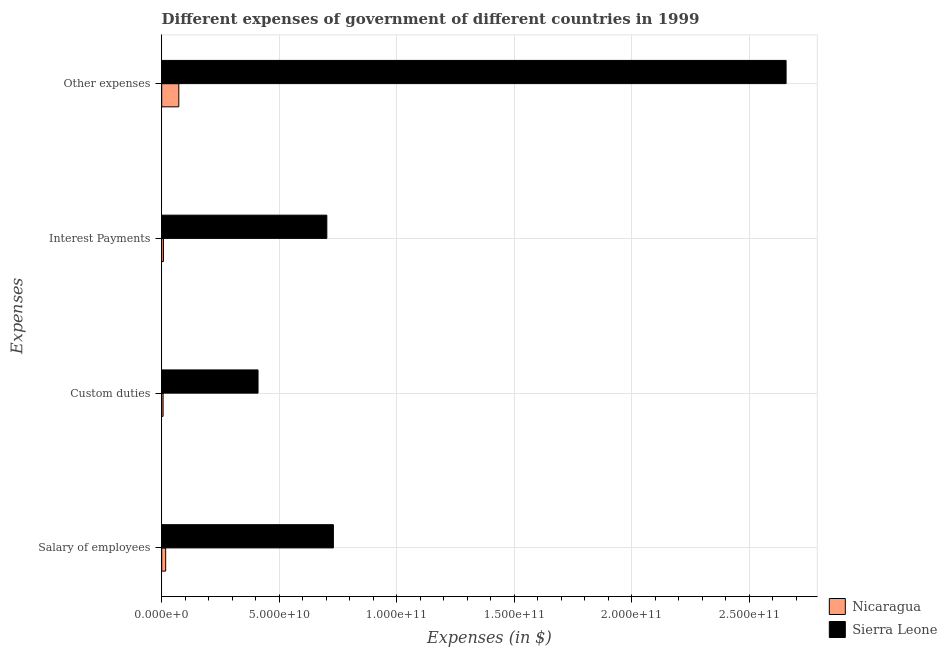How many groups of bars are there?
Give a very brief answer. 4. Are the number of bars per tick equal to the number of legend labels?
Your answer should be compact. Yes. Are the number of bars on each tick of the Y-axis equal?
Provide a short and direct response. Yes. How many bars are there on the 3rd tick from the top?
Offer a very short reply. 2. What is the label of the 2nd group of bars from the top?
Keep it short and to the point. Interest Payments. What is the amount spent on other expenses in Nicaragua?
Offer a very short reply. 7.27e+09. Across all countries, what is the maximum amount spent on custom duties?
Give a very brief answer. 4.10e+1. Across all countries, what is the minimum amount spent on other expenses?
Provide a short and direct response. 7.27e+09. In which country was the amount spent on other expenses maximum?
Provide a short and direct response. Sierra Leone. In which country was the amount spent on other expenses minimum?
Offer a terse response. Nicaragua. What is the total amount spent on custom duties in the graph?
Ensure brevity in your answer.  4.16e+1. What is the difference between the amount spent on salary of employees in Sierra Leone and that in Nicaragua?
Make the answer very short. 7.13e+1. What is the difference between the amount spent on interest payments in Nicaragua and the amount spent on custom duties in Sierra Leone?
Provide a succinct answer. -4.02e+1. What is the average amount spent on salary of employees per country?
Make the answer very short. 3.74e+1. What is the difference between the amount spent on interest payments and amount spent on custom duties in Sierra Leone?
Ensure brevity in your answer.  2.93e+1. In how many countries, is the amount spent on salary of employees greater than 100000000000 $?
Your response must be concise. 0. What is the ratio of the amount spent on custom duties in Sierra Leone to that in Nicaragua?
Provide a succinct answer. 69.95. Is the amount spent on other expenses in Nicaragua less than that in Sierra Leone?
Offer a very short reply. Yes. What is the difference between the highest and the second highest amount spent on interest payments?
Provide a succinct answer. 6.95e+1. What is the difference between the highest and the lowest amount spent on custom duties?
Make the answer very short. 4.04e+1. In how many countries, is the amount spent on custom duties greater than the average amount spent on custom duties taken over all countries?
Provide a succinct answer. 1. Is the sum of the amount spent on salary of employees in Sierra Leone and Nicaragua greater than the maximum amount spent on custom duties across all countries?
Keep it short and to the point. Yes. Is it the case that in every country, the sum of the amount spent on salary of employees and amount spent on other expenses is greater than the sum of amount spent on interest payments and amount spent on custom duties?
Your answer should be very brief. No. What does the 2nd bar from the top in Salary of employees represents?
Your response must be concise. Nicaragua. What does the 2nd bar from the bottom in Other expenses represents?
Your response must be concise. Sierra Leone. How many bars are there?
Provide a succinct answer. 8. Are all the bars in the graph horizontal?
Your answer should be very brief. Yes. How many countries are there in the graph?
Offer a very short reply. 2. Does the graph contain any zero values?
Your answer should be very brief. No. Does the graph contain grids?
Your answer should be compact. Yes. How many legend labels are there?
Make the answer very short. 2. What is the title of the graph?
Make the answer very short. Different expenses of government of different countries in 1999. What is the label or title of the X-axis?
Offer a very short reply. Expenses (in $). What is the label or title of the Y-axis?
Your answer should be compact. Expenses. What is the Expenses (in $) in Nicaragua in Salary of employees?
Keep it short and to the point. 1.68e+09. What is the Expenses (in $) of Sierra Leone in Salary of employees?
Offer a very short reply. 7.30e+1. What is the Expenses (in $) of Nicaragua in Custom duties?
Offer a terse response. 5.86e+08. What is the Expenses (in $) in Sierra Leone in Custom duties?
Ensure brevity in your answer.  4.10e+1. What is the Expenses (in $) of Nicaragua in Interest Payments?
Your answer should be very brief. 7.43e+08. What is the Expenses (in $) of Sierra Leone in Interest Payments?
Ensure brevity in your answer.  7.02e+1. What is the Expenses (in $) in Nicaragua in Other expenses?
Provide a short and direct response. 7.27e+09. What is the Expenses (in $) in Sierra Leone in Other expenses?
Keep it short and to the point. 2.66e+11. Across all Expenses, what is the maximum Expenses (in $) of Nicaragua?
Offer a terse response. 7.27e+09. Across all Expenses, what is the maximum Expenses (in $) of Sierra Leone?
Your answer should be compact. 2.66e+11. Across all Expenses, what is the minimum Expenses (in $) in Nicaragua?
Provide a succinct answer. 5.86e+08. Across all Expenses, what is the minimum Expenses (in $) in Sierra Leone?
Keep it short and to the point. 4.10e+1. What is the total Expenses (in $) of Nicaragua in the graph?
Make the answer very short. 1.03e+1. What is the total Expenses (in $) of Sierra Leone in the graph?
Your answer should be very brief. 4.50e+11. What is the difference between the Expenses (in $) in Nicaragua in Salary of employees and that in Custom duties?
Your response must be concise. 1.10e+09. What is the difference between the Expenses (in $) of Sierra Leone in Salary of employees and that in Custom duties?
Provide a succinct answer. 3.21e+1. What is the difference between the Expenses (in $) of Nicaragua in Salary of employees and that in Interest Payments?
Give a very brief answer. 9.40e+08. What is the difference between the Expenses (in $) of Sierra Leone in Salary of employees and that in Interest Payments?
Keep it short and to the point. 2.79e+09. What is the difference between the Expenses (in $) in Nicaragua in Salary of employees and that in Other expenses?
Provide a succinct answer. -5.59e+09. What is the difference between the Expenses (in $) of Sierra Leone in Salary of employees and that in Other expenses?
Provide a short and direct response. -1.93e+11. What is the difference between the Expenses (in $) in Nicaragua in Custom duties and that in Interest Payments?
Give a very brief answer. -1.57e+08. What is the difference between the Expenses (in $) in Sierra Leone in Custom duties and that in Interest Payments?
Make the answer very short. -2.93e+1. What is the difference between the Expenses (in $) in Nicaragua in Custom duties and that in Other expenses?
Offer a terse response. -6.69e+09. What is the difference between the Expenses (in $) of Sierra Leone in Custom duties and that in Other expenses?
Give a very brief answer. -2.25e+11. What is the difference between the Expenses (in $) of Nicaragua in Interest Payments and that in Other expenses?
Ensure brevity in your answer.  -6.53e+09. What is the difference between the Expenses (in $) in Sierra Leone in Interest Payments and that in Other expenses?
Offer a very short reply. -1.95e+11. What is the difference between the Expenses (in $) in Nicaragua in Salary of employees and the Expenses (in $) in Sierra Leone in Custom duties?
Offer a terse response. -3.93e+1. What is the difference between the Expenses (in $) in Nicaragua in Salary of employees and the Expenses (in $) in Sierra Leone in Interest Payments?
Offer a very short reply. -6.86e+1. What is the difference between the Expenses (in $) in Nicaragua in Salary of employees and the Expenses (in $) in Sierra Leone in Other expenses?
Your response must be concise. -2.64e+11. What is the difference between the Expenses (in $) of Nicaragua in Custom duties and the Expenses (in $) of Sierra Leone in Interest Payments?
Offer a terse response. -6.97e+1. What is the difference between the Expenses (in $) of Nicaragua in Custom duties and the Expenses (in $) of Sierra Leone in Other expenses?
Provide a succinct answer. -2.65e+11. What is the difference between the Expenses (in $) in Nicaragua in Interest Payments and the Expenses (in $) in Sierra Leone in Other expenses?
Make the answer very short. -2.65e+11. What is the average Expenses (in $) of Nicaragua per Expenses?
Provide a short and direct response. 2.57e+09. What is the average Expenses (in $) in Sierra Leone per Expenses?
Make the answer very short. 1.12e+11. What is the difference between the Expenses (in $) of Nicaragua and Expenses (in $) of Sierra Leone in Salary of employees?
Offer a very short reply. -7.13e+1. What is the difference between the Expenses (in $) of Nicaragua and Expenses (in $) of Sierra Leone in Custom duties?
Offer a very short reply. -4.04e+1. What is the difference between the Expenses (in $) in Nicaragua and Expenses (in $) in Sierra Leone in Interest Payments?
Provide a succinct answer. -6.95e+1. What is the difference between the Expenses (in $) in Nicaragua and Expenses (in $) in Sierra Leone in Other expenses?
Keep it short and to the point. -2.58e+11. What is the ratio of the Expenses (in $) of Nicaragua in Salary of employees to that in Custom duties?
Your response must be concise. 2.87. What is the ratio of the Expenses (in $) in Sierra Leone in Salary of employees to that in Custom duties?
Offer a very short reply. 1.78. What is the ratio of the Expenses (in $) of Nicaragua in Salary of employees to that in Interest Payments?
Your response must be concise. 2.27. What is the ratio of the Expenses (in $) of Sierra Leone in Salary of employees to that in Interest Payments?
Provide a short and direct response. 1.04. What is the ratio of the Expenses (in $) in Nicaragua in Salary of employees to that in Other expenses?
Give a very brief answer. 0.23. What is the ratio of the Expenses (in $) of Sierra Leone in Salary of employees to that in Other expenses?
Provide a succinct answer. 0.28. What is the ratio of the Expenses (in $) of Nicaragua in Custom duties to that in Interest Payments?
Offer a very short reply. 0.79. What is the ratio of the Expenses (in $) of Sierra Leone in Custom duties to that in Interest Payments?
Offer a terse response. 0.58. What is the ratio of the Expenses (in $) in Nicaragua in Custom duties to that in Other expenses?
Your answer should be very brief. 0.08. What is the ratio of the Expenses (in $) in Sierra Leone in Custom duties to that in Other expenses?
Provide a short and direct response. 0.15. What is the ratio of the Expenses (in $) in Nicaragua in Interest Payments to that in Other expenses?
Provide a succinct answer. 0.1. What is the ratio of the Expenses (in $) in Sierra Leone in Interest Payments to that in Other expenses?
Your answer should be very brief. 0.26. What is the difference between the highest and the second highest Expenses (in $) in Nicaragua?
Make the answer very short. 5.59e+09. What is the difference between the highest and the second highest Expenses (in $) of Sierra Leone?
Make the answer very short. 1.93e+11. What is the difference between the highest and the lowest Expenses (in $) in Nicaragua?
Your answer should be compact. 6.69e+09. What is the difference between the highest and the lowest Expenses (in $) of Sierra Leone?
Your answer should be compact. 2.25e+11. 